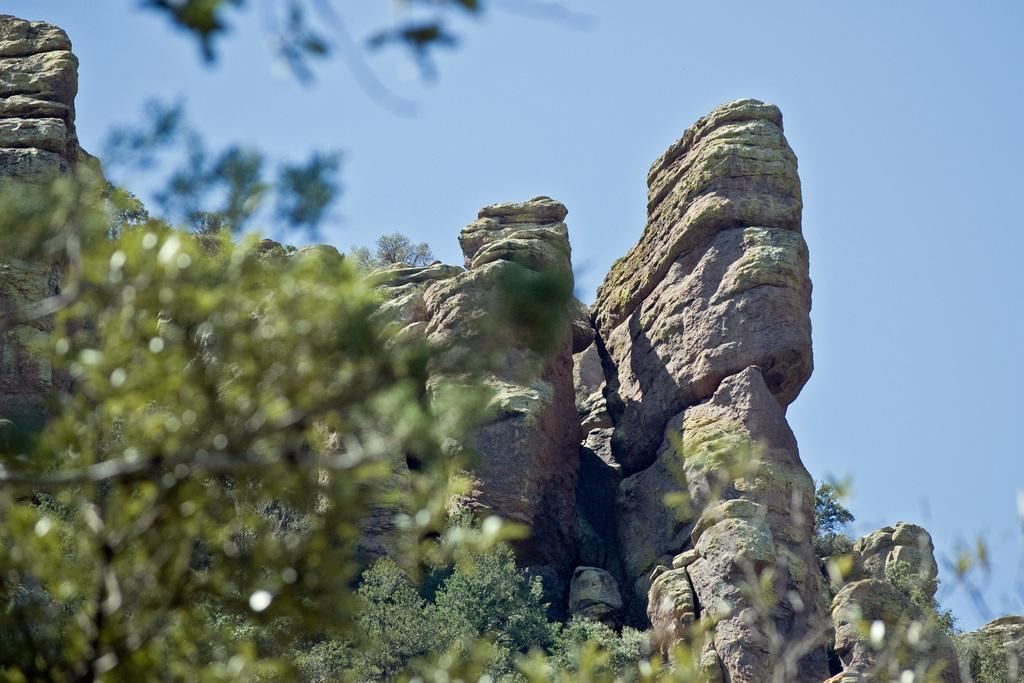What type of natural elements can be seen in the image? There are rocks and trees in the image. What part of the natural environment is visible in the image? The sky is visible in the image. What type of door can be seen in the image? There is no door present in the image; it features rocks, trees, and the sky. What type of attraction is depicted in the image? There is no specific attraction depicted in the image; it simply shows rocks, trees, and the sky. 